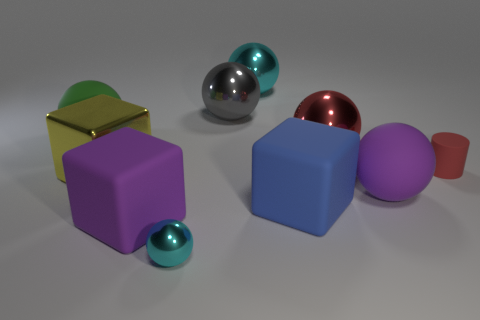Is there anything else that has the same material as the big purple cube?
Offer a very short reply. Yes. What is the color of the big metallic ball in front of the gray metallic sphere?
Your response must be concise. Red. Is the material of the small cyan thing the same as the large purple ball that is in front of the large cyan shiny object?
Offer a very short reply. No. What is the material of the purple ball?
Your answer should be very brief. Rubber. What is the shape of the small cyan object that is the same material as the yellow thing?
Give a very brief answer. Sphere. What number of other objects are there of the same shape as the big gray object?
Your answer should be compact. 5. What number of small matte cylinders are in front of the small cyan ball?
Your answer should be very brief. 0. There is a cyan shiny ball that is behind the matte cylinder; is it the same size as the matte sphere to the left of the large red object?
Ensure brevity in your answer.  Yes. How many other objects are there of the same size as the yellow cube?
Keep it short and to the point. 7. The purple thing that is in front of the purple object that is on the right side of the purple matte thing to the left of the big blue matte block is made of what material?
Give a very brief answer. Rubber. 